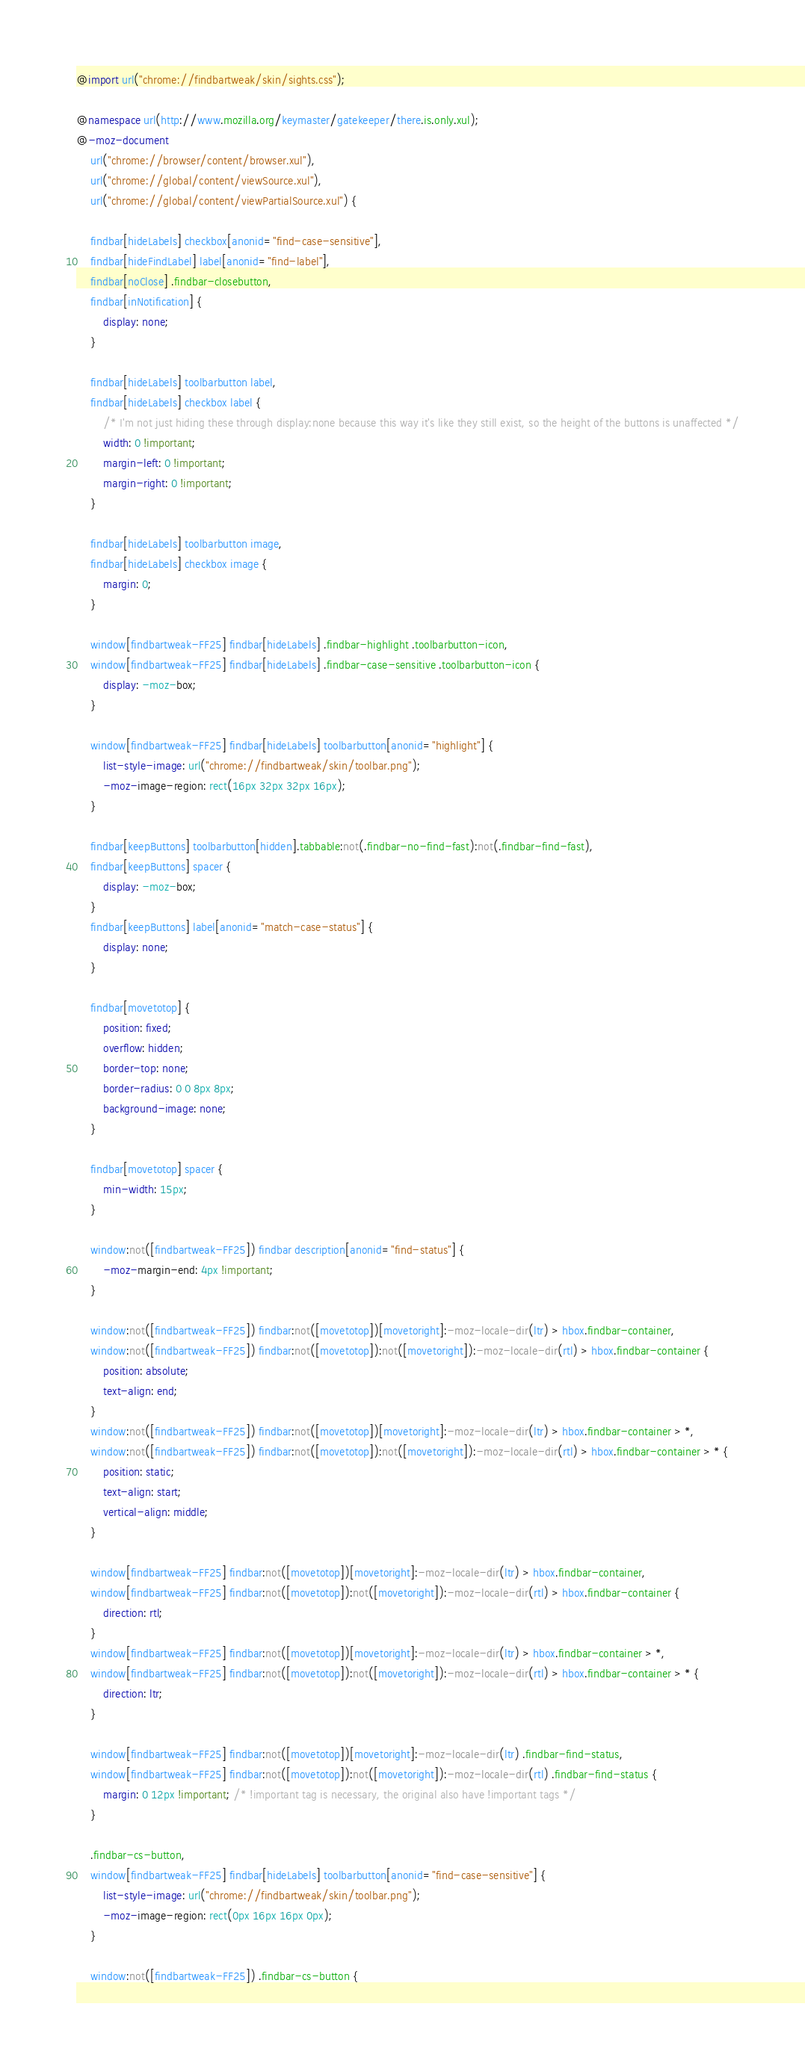Convert code to text. <code><loc_0><loc_0><loc_500><loc_500><_CSS_>@import url("chrome://findbartweak/skin/sights.css");

@namespace url(http://www.mozilla.org/keymaster/gatekeeper/there.is.only.xul);
@-moz-document
	url("chrome://browser/content/browser.xul"),
	url("chrome://global/content/viewSource.xul"),
	url("chrome://global/content/viewPartialSource.xul") {

	findbar[hideLabels] checkbox[anonid="find-case-sensitive"],
	findbar[hideFindLabel] label[anonid="find-label"],
	findbar[noClose] .findbar-closebutton,
	findbar[inNotification] {
		display: none;
	}
	
	findbar[hideLabels] toolbarbutton label,
	findbar[hideLabels] checkbox label {
		/* I'm not just hiding these through display:none because this way it's like they still exist, so the height of the buttons is unaffected */
		width: 0 !important;
		margin-left: 0 !important;
		margin-right: 0 !important;
	}
	
	findbar[hideLabels] toolbarbutton image,
	findbar[hideLabels] checkbox image {
		margin: 0;
	}
	
	window[findbartweak-FF25] findbar[hideLabels] .findbar-highlight .toolbarbutton-icon,
	window[findbartweak-FF25] findbar[hideLabels] .findbar-case-sensitive .toolbarbutton-icon {
		display: -moz-box;
	}
	
	window[findbartweak-FF25] findbar[hideLabels] toolbarbutton[anonid="highlight"] {
		list-style-image: url("chrome://findbartweak/skin/toolbar.png");
		-moz-image-region: rect(16px 32px 32px 16px);
	}
	
	findbar[keepButtons] toolbarbutton[hidden].tabbable:not(.findbar-no-find-fast):not(.findbar-find-fast),
	findbar[keepButtons] spacer {
		display: -moz-box;
	}
	findbar[keepButtons] label[anonid="match-case-status"] {
		display: none;
	}
	
	findbar[movetotop] {
		position: fixed;
		overflow: hidden;
		border-top: none;
		border-radius: 0 0 8px 8px;
		background-image: none;
	}
	
	findbar[movetotop] spacer {
		min-width: 15px;
	}
	
	window:not([findbartweak-FF25]) findbar description[anonid="find-status"] {
		-moz-margin-end: 4px !important;
	}
	
	window:not([findbartweak-FF25]) findbar:not([movetotop])[movetoright]:-moz-locale-dir(ltr) > hbox.findbar-container,
	window:not([findbartweak-FF25]) findbar:not([movetotop]):not([movetoright]):-moz-locale-dir(rtl) > hbox.findbar-container {
		position: absolute;
		text-align: end;
	}
	window:not([findbartweak-FF25]) findbar:not([movetotop])[movetoright]:-moz-locale-dir(ltr) > hbox.findbar-container > *,
	window:not([findbartweak-FF25]) findbar:not([movetotop]):not([movetoright]):-moz-locale-dir(rtl) > hbox.findbar-container > * {
		position: static;
		text-align: start;
		vertical-align: middle;
	}
	
	window[findbartweak-FF25] findbar:not([movetotop])[movetoright]:-moz-locale-dir(ltr) > hbox.findbar-container,
	window[findbartweak-FF25] findbar:not([movetotop]):not([movetoright]):-moz-locale-dir(rtl) > hbox.findbar-container {
		direction: rtl;
	}
	window[findbartweak-FF25] findbar:not([movetotop])[movetoright]:-moz-locale-dir(ltr) > hbox.findbar-container > *,
	window[findbartweak-FF25] findbar:not([movetotop]):not([movetoright]):-moz-locale-dir(rtl) > hbox.findbar-container > * {
		direction: ltr;
	}
	
	window[findbartweak-FF25] findbar:not([movetotop])[movetoright]:-moz-locale-dir(ltr) .findbar-find-status,
	window[findbartweak-FF25] findbar:not([movetotop]):not([movetoright]):-moz-locale-dir(rtl) .findbar-find-status {
		margin: 0 12px !important; /* !important tag is necessary, the original also have !important tags */
	}
	
	.findbar-cs-button,
	window[findbartweak-FF25] findbar[hideLabels] toolbarbutton[anonid="find-case-sensitive"] {
		list-style-image: url("chrome://findbartweak/skin/toolbar.png");
		-moz-image-region: rect(0px 16px 16px 0px);
	}
	
	window:not([findbartweak-FF25]) .findbar-cs-button {</code> 